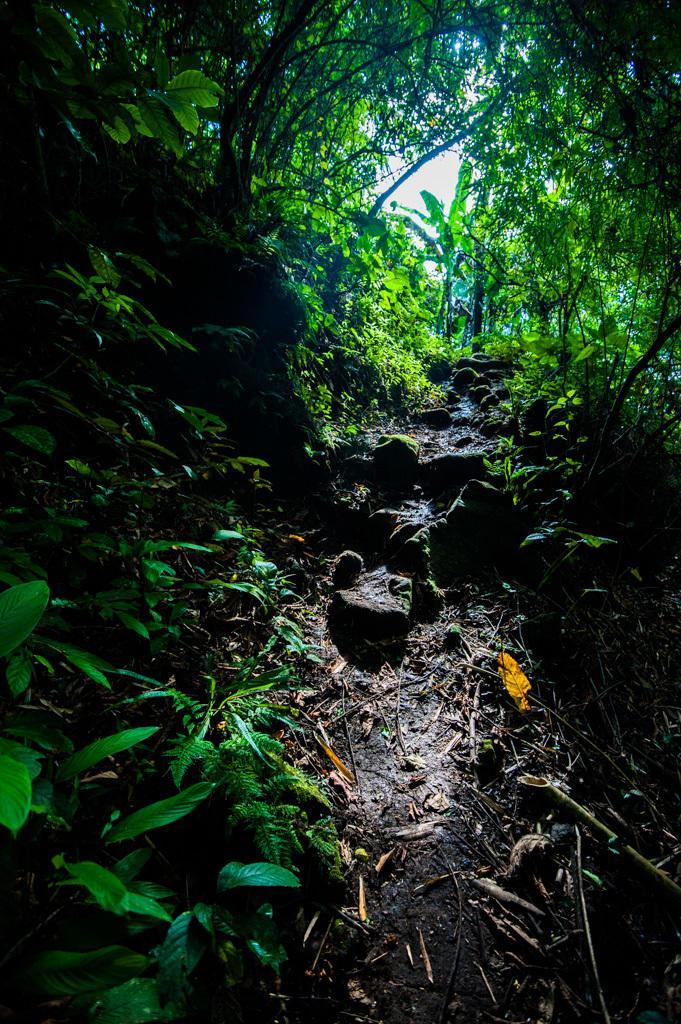In one or two sentences, can you explain what this image depicts? This is a picture taken in the fields. In the center of the picture there are stones and debris. On the left there are plants and trees. On the right there are plants and trees. In the background there are trees. 